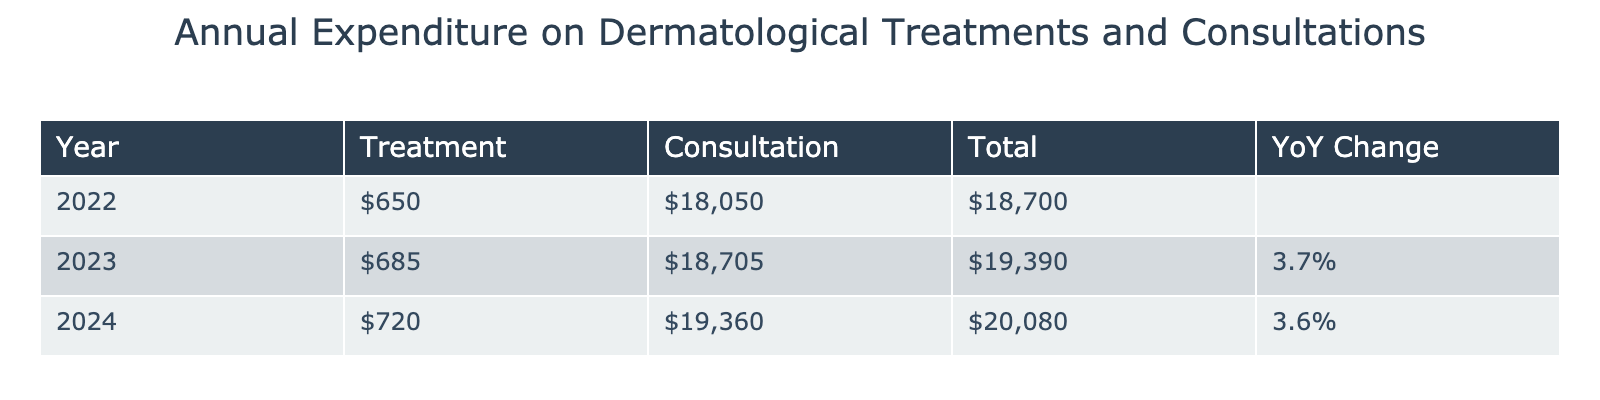What was the total expenditure on dermatological treatments in 2022? To find the total expenditure on treatments for 2022, we sum the costs of all treatment types listed for that year: Topical Steroids ($200) + Biologic Injections ($15,000) + Light Therapy ($1,200) + Prescription Pills ($800) + Natural Moisturizers ($100) + Antibiotic Creams ($250) + Prescription Ointments ($500) = $17,050.
Answer: $17,050 How much did the cost of the dermatologist's initial visit increase from 2022 to 2024? The cost for the dermatologist's initial visit in 2022 was $200, and in 2024 it was $220. To find the increase, we calculate $220 - $200 = $20.
Answer: $20 What was the total expenditure on consultations in 2023? To find the total expenditure on consultations for 2023, we sum the costs of all consultation types: Dermatologist Initial Visit ($210) + Dermatologist Follow-up Visit ($160) + Specialist Consultation ($315) = $685.
Answer: $685 Did the total expenditure on treatments decrease from 2023 to 2024? We need to calculate the total treatments for both years: In 2023, the total for treatments is: Topical Steroids ($210) + Biologic Injections ($15,500) + Light Therapy ($1,250) + Prescription Pills ($850) + Natural Moisturizers ($110) + Antibiotic Creams ($260) + Prescription Ointments ($525) = $18,705. For 2024, the total is: Topical Steroids ($220) + Biologic Injections ($16,000) + Light Therapy ($1,300) + Prescription Pills ($900) + Natural Moisturizers ($120) + Antibiotic Creams ($270) + Prescription Ointments ($550) = $19,360. Since $18,705 is less than $19,360, the expenditure did not decrease, it increased.
Answer: No What is the percentage increase in total treatment costs from 2022 to 2023? The total treatment costs for 2022 is $17,050 and for 2023 it is $18,705. To find the percentage increase, we calculate: (($18,705 - $17,050) / $17,050) * 100 = 9.69%.
Answer: 9.69% What was the average annual expenditure on specialist consultations over the three years? For specialist consultations, we have the following costs: 2022 ($300) + 2023 ($315) + 2024 ($330) = $945. To find the average, we divide by the number of years, which is 3: $945 / 3 = $315.
Answer: $315 